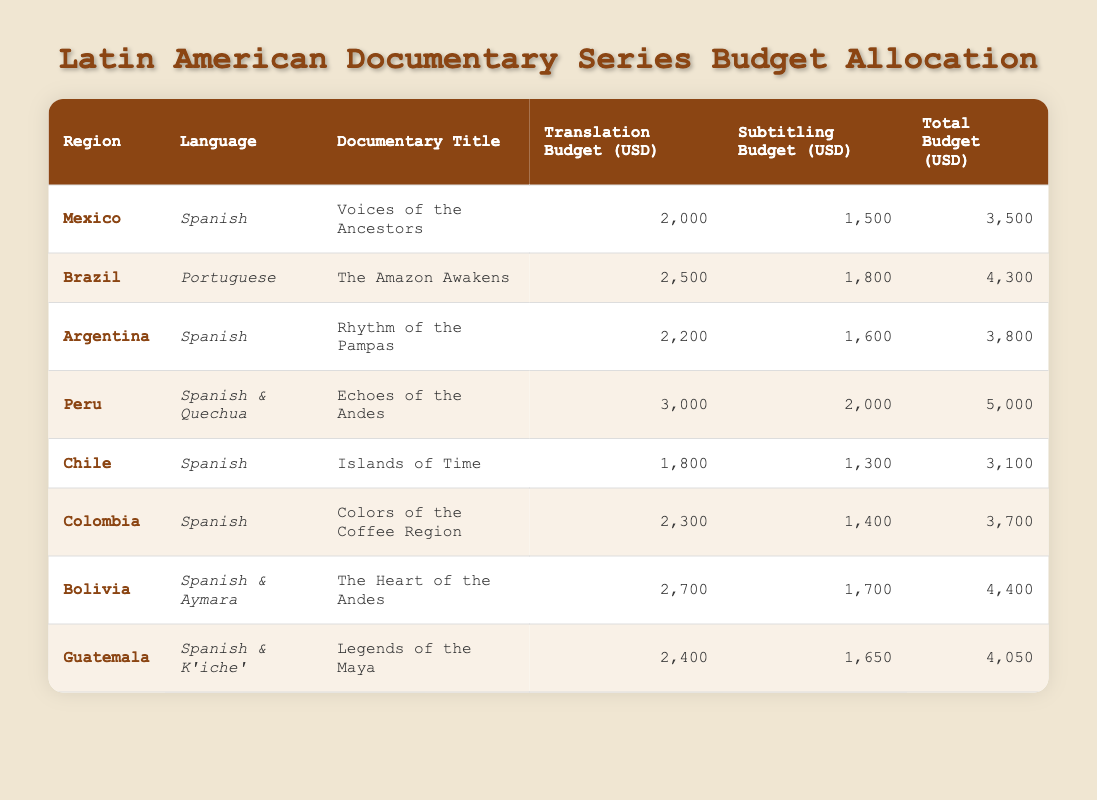What is the total budget allocated for the documentary "Voices of the Ancestors"? The total budget for "Voices of the Ancestors" in Mexico is listed directly in the table under the "Total Budget (USD)" column, which shows 3500 USD.
Answer: 3500 Which documentary has the highest translation budget? By looking at the "Translation Budget (USD)" column, we see that "Echoes of the Andes" has the highest translation budget of 3000 USD.
Answer: Echoes of the Andes Is the total budget for the documentary "The Amazon Awakens" greater than 4000 USD? The total budget for "The Amazon Awakens" in Brazil is 4300 USD, which is indeed greater than 4000 USD, validating the statement as true.
Answer: Yes What is the average subtitling budget across all documentaries? To find the average, we sum the subtitling budgets (1500 + 1800 + 1600 + 2000 + 1300 + 1400 + 1700 + 1650 = 11550 USD), and divide by the number of documentaries (8). So, 11550/8 = 1443.75.
Answer: 1443.75 Which region has the largest combined budget for translation and subtitling? By adding the translation and subtitling budgets for each region, we find that Peru has the highest total at 5000 USD (3000 + 2000).
Answer: Peru 